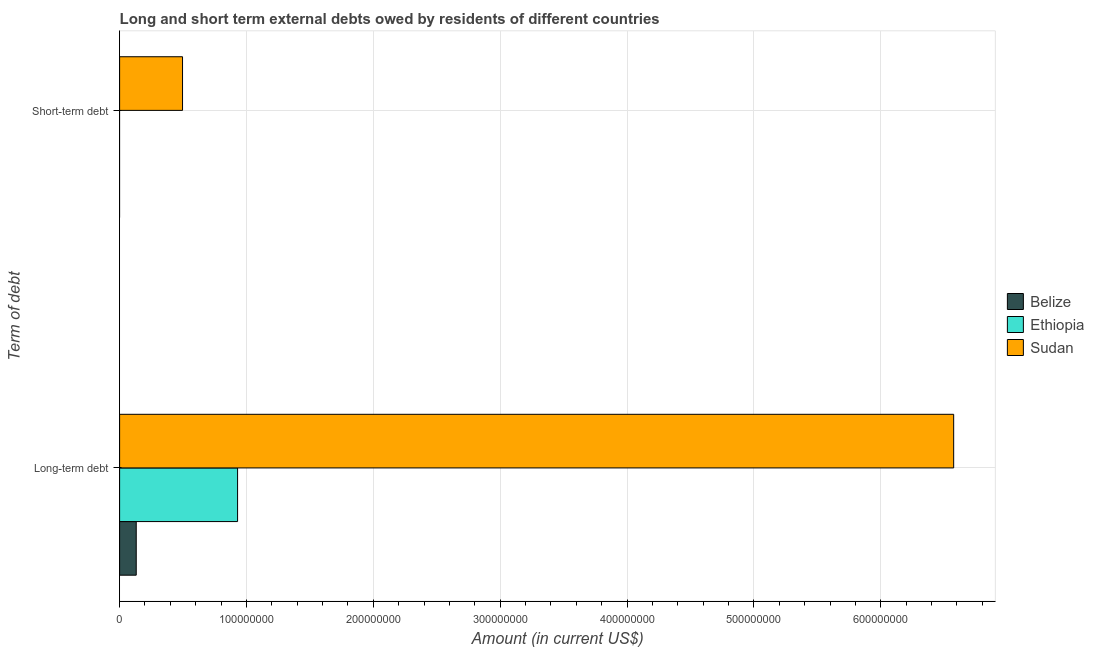What is the label of the 1st group of bars from the top?
Ensure brevity in your answer.  Short-term debt. Across all countries, what is the maximum short-term debts owed by residents?
Provide a succinct answer. 4.96e+07. In which country was the short-term debts owed by residents maximum?
Your response must be concise. Sudan. What is the total short-term debts owed by residents in the graph?
Your answer should be very brief. 4.96e+07. What is the difference between the long-term debts owed by residents in Belize and that in Ethiopia?
Provide a short and direct response. -7.99e+07. What is the difference between the short-term debts owed by residents in Belize and the long-term debts owed by residents in Ethiopia?
Ensure brevity in your answer.  -9.30e+07. What is the average long-term debts owed by residents per country?
Offer a terse response. 2.55e+08. What is the difference between the short-term debts owed by residents and long-term debts owed by residents in Sudan?
Your answer should be very brief. -6.08e+08. In how many countries, is the short-term debts owed by residents greater than 620000000 US$?
Your answer should be compact. 0. What is the ratio of the long-term debts owed by residents in Belize to that in Sudan?
Offer a very short reply. 0.02. Is the long-term debts owed by residents in Ethiopia less than that in Sudan?
Your answer should be compact. Yes. In how many countries, is the long-term debts owed by residents greater than the average long-term debts owed by residents taken over all countries?
Offer a terse response. 1. Are all the bars in the graph horizontal?
Keep it short and to the point. Yes. How many countries are there in the graph?
Make the answer very short. 3. Are the values on the major ticks of X-axis written in scientific E-notation?
Keep it short and to the point. No. Does the graph contain any zero values?
Offer a terse response. Yes. Where does the legend appear in the graph?
Give a very brief answer. Center right. How many legend labels are there?
Your response must be concise. 3. How are the legend labels stacked?
Keep it short and to the point. Vertical. What is the title of the graph?
Ensure brevity in your answer.  Long and short term external debts owed by residents of different countries. Does "Algeria" appear as one of the legend labels in the graph?
Give a very brief answer. No. What is the label or title of the X-axis?
Your response must be concise. Amount (in current US$). What is the label or title of the Y-axis?
Make the answer very short. Term of debt. What is the Amount (in current US$) of Belize in Long-term debt?
Make the answer very short. 1.31e+07. What is the Amount (in current US$) of Ethiopia in Long-term debt?
Offer a terse response. 9.30e+07. What is the Amount (in current US$) in Sudan in Long-term debt?
Ensure brevity in your answer.  6.57e+08. What is the Amount (in current US$) of Belize in Short-term debt?
Provide a short and direct response. 0. What is the Amount (in current US$) of Ethiopia in Short-term debt?
Give a very brief answer. 0. What is the Amount (in current US$) of Sudan in Short-term debt?
Keep it short and to the point. 4.96e+07. Across all Term of debt, what is the maximum Amount (in current US$) of Belize?
Keep it short and to the point. 1.31e+07. Across all Term of debt, what is the maximum Amount (in current US$) in Ethiopia?
Offer a terse response. 9.30e+07. Across all Term of debt, what is the maximum Amount (in current US$) of Sudan?
Offer a terse response. 6.57e+08. Across all Term of debt, what is the minimum Amount (in current US$) in Sudan?
Give a very brief answer. 4.96e+07. What is the total Amount (in current US$) in Belize in the graph?
Your answer should be compact. 1.31e+07. What is the total Amount (in current US$) in Ethiopia in the graph?
Your response must be concise. 9.30e+07. What is the total Amount (in current US$) in Sudan in the graph?
Make the answer very short. 7.07e+08. What is the difference between the Amount (in current US$) in Sudan in Long-term debt and that in Short-term debt?
Keep it short and to the point. 6.08e+08. What is the difference between the Amount (in current US$) of Belize in Long-term debt and the Amount (in current US$) of Sudan in Short-term debt?
Make the answer very short. -3.65e+07. What is the difference between the Amount (in current US$) of Ethiopia in Long-term debt and the Amount (in current US$) of Sudan in Short-term debt?
Your response must be concise. 4.34e+07. What is the average Amount (in current US$) in Belize per Term of debt?
Provide a succinct answer. 6.55e+06. What is the average Amount (in current US$) of Ethiopia per Term of debt?
Provide a succinct answer. 4.65e+07. What is the average Amount (in current US$) in Sudan per Term of debt?
Make the answer very short. 3.54e+08. What is the difference between the Amount (in current US$) in Belize and Amount (in current US$) in Ethiopia in Long-term debt?
Ensure brevity in your answer.  -7.99e+07. What is the difference between the Amount (in current US$) in Belize and Amount (in current US$) in Sudan in Long-term debt?
Offer a very short reply. -6.44e+08. What is the difference between the Amount (in current US$) of Ethiopia and Amount (in current US$) of Sudan in Long-term debt?
Keep it short and to the point. -5.64e+08. What is the ratio of the Amount (in current US$) of Sudan in Long-term debt to that in Short-term debt?
Make the answer very short. 13.26. What is the difference between the highest and the second highest Amount (in current US$) of Sudan?
Your response must be concise. 6.08e+08. What is the difference between the highest and the lowest Amount (in current US$) of Belize?
Provide a short and direct response. 1.31e+07. What is the difference between the highest and the lowest Amount (in current US$) of Ethiopia?
Your answer should be compact. 9.30e+07. What is the difference between the highest and the lowest Amount (in current US$) in Sudan?
Give a very brief answer. 6.08e+08. 